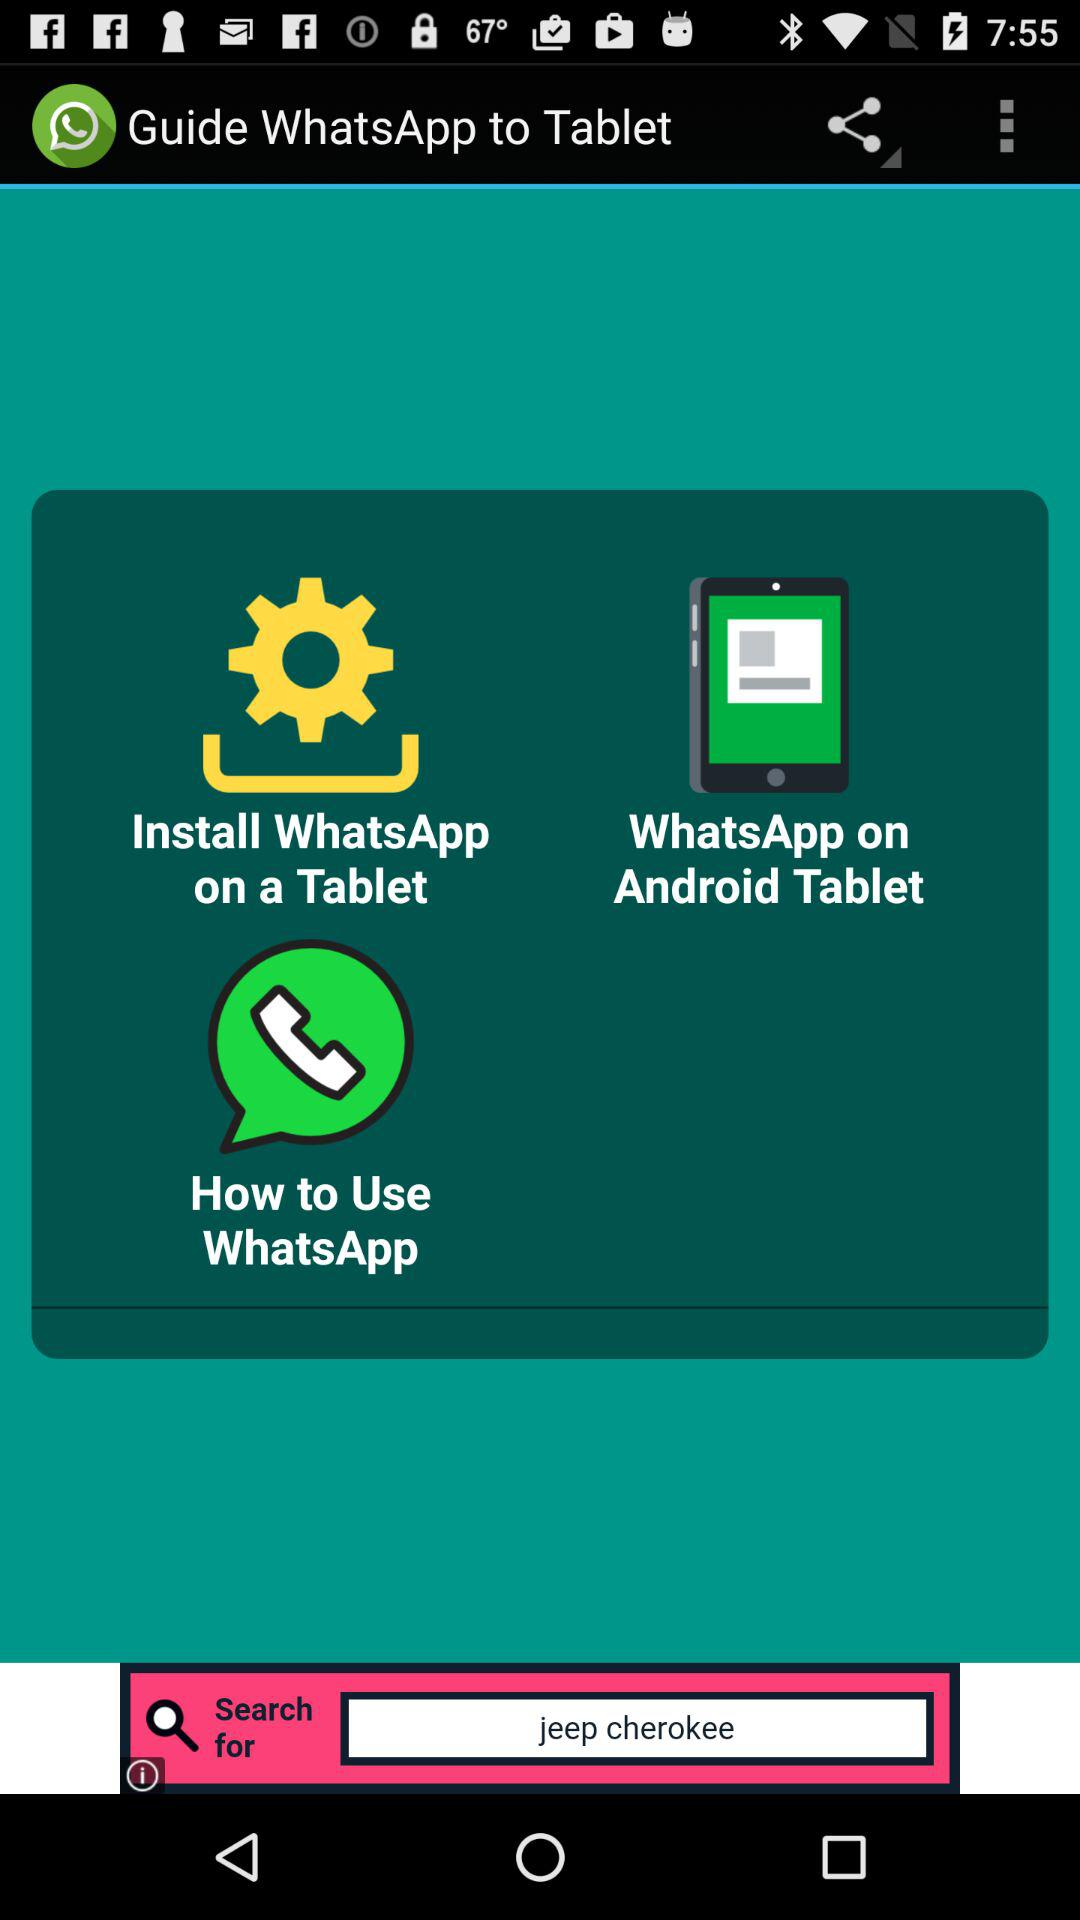What input text did you enter in the search box?
When the provided information is insufficient, respond with <no answer>. <no answer> 